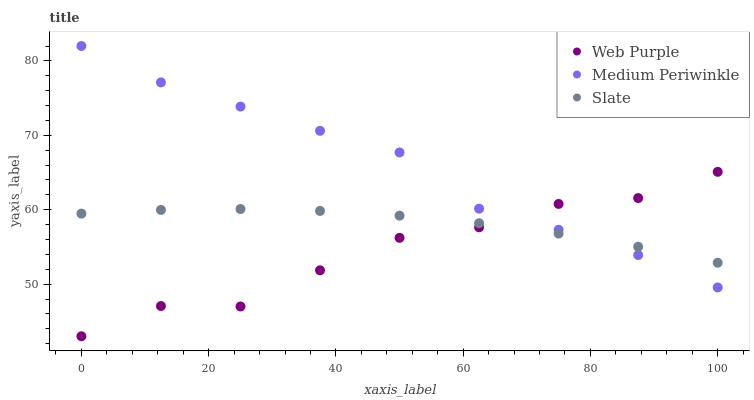Does Web Purple have the minimum area under the curve?
Answer yes or no. Yes. Does Medium Periwinkle have the maximum area under the curve?
Answer yes or no. Yes. Does Slate have the minimum area under the curve?
Answer yes or no. No. Does Slate have the maximum area under the curve?
Answer yes or no. No. Is Slate the smoothest?
Answer yes or no. Yes. Is Web Purple the roughest?
Answer yes or no. Yes. Is Medium Periwinkle the smoothest?
Answer yes or no. No. Is Medium Periwinkle the roughest?
Answer yes or no. No. Does Web Purple have the lowest value?
Answer yes or no. Yes. Does Medium Periwinkle have the lowest value?
Answer yes or no. No. Does Medium Periwinkle have the highest value?
Answer yes or no. Yes. Does Slate have the highest value?
Answer yes or no. No. Does Web Purple intersect Slate?
Answer yes or no. Yes. Is Web Purple less than Slate?
Answer yes or no. No. Is Web Purple greater than Slate?
Answer yes or no. No. 